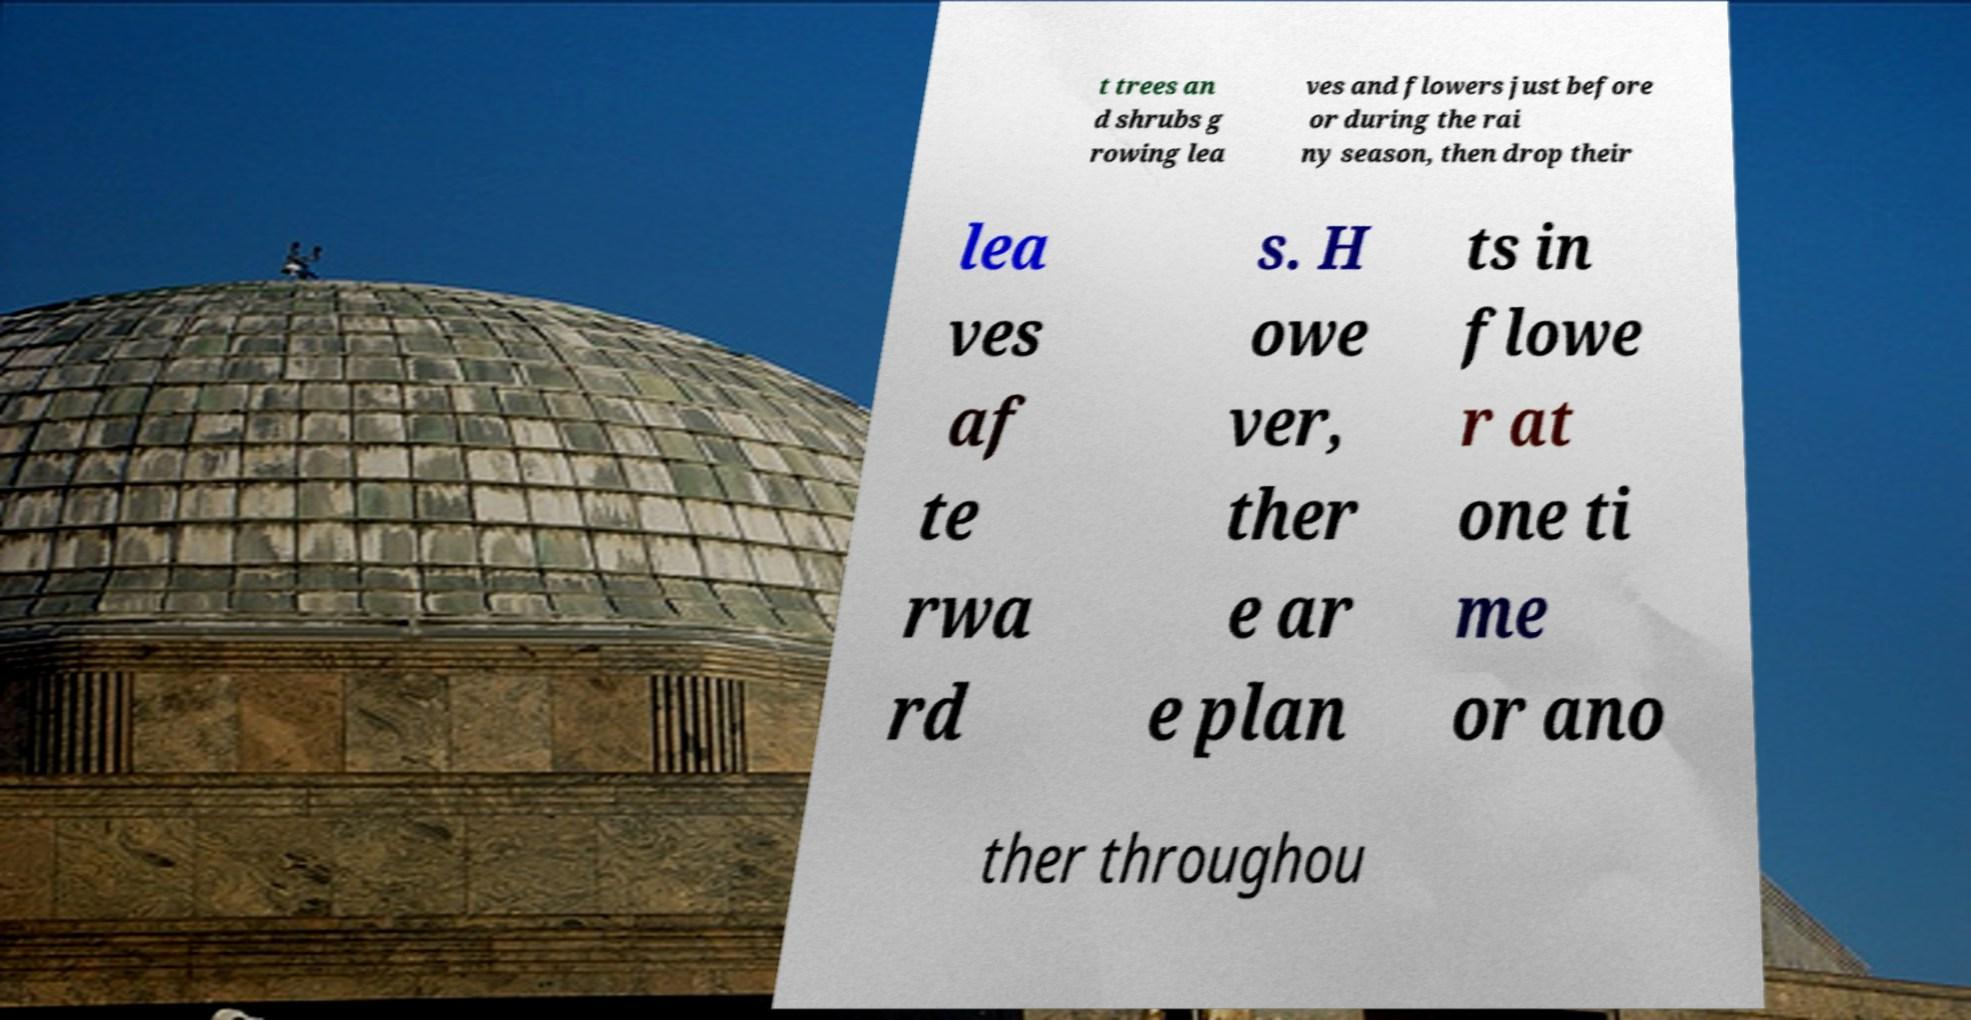I need the written content from this picture converted into text. Can you do that? t trees an d shrubs g rowing lea ves and flowers just before or during the rai ny season, then drop their lea ves af te rwa rd s. H owe ver, ther e ar e plan ts in flowe r at one ti me or ano ther throughou 